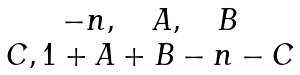Convert formula to latex. <formula><loc_0><loc_0><loc_500><loc_500>\begin{matrix} - n , \quad A , \quad B \\ C , 1 + A + B - n - C \end{matrix}</formula> 